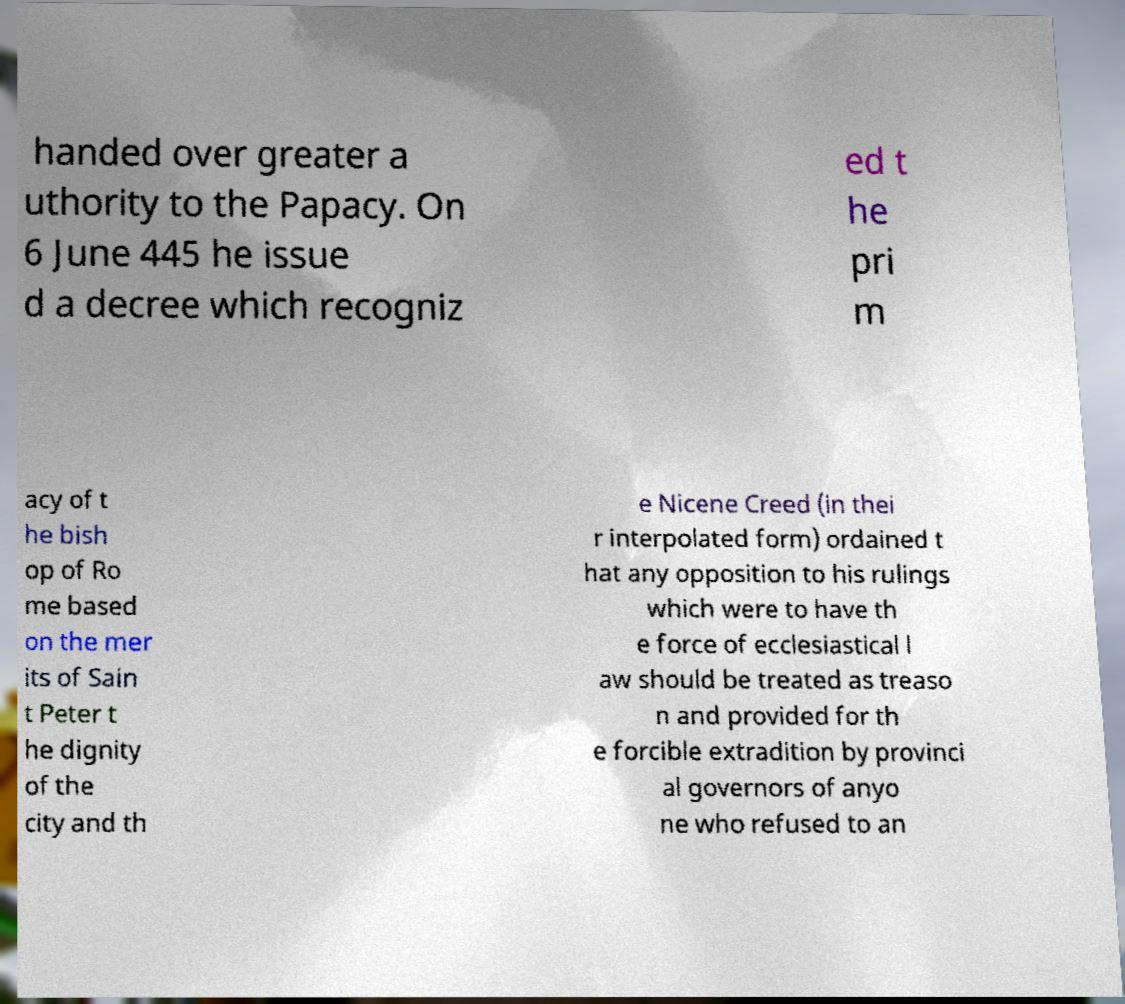Can you read and provide the text displayed in the image?This photo seems to have some interesting text. Can you extract and type it out for me? handed over greater a uthority to the Papacy. On 6 June 445 he issue d a decree which recogniz ed t he pri m acy of t he bish op of Ro me based on the mer its of Sain t Peter t he dignity of the city and th e Nicene Creed (in thei r interpolated form) ordained t hat any opposition to his rulings which were to have th e force of ecclesiastical l aw should be treated as treaso n and provided for th e forcible extradition by provinci al governors of anyo ne who refused to an 